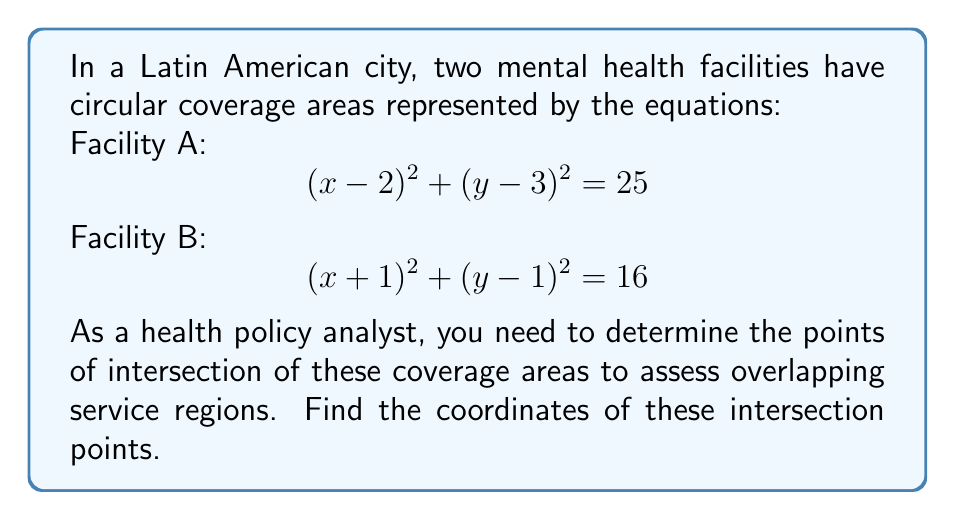Can you solve this math problem? To find the intersection points of these two circular coverage areas, we need to solve the system of equations:

1) $$(x-2)^2 + (y-3)^2 = 25$$
2) $$(x+1)^2 + (y-1)^2 = 16$$

Step 1: Expand the equations
1) $$x^2 - 4x + 4 + y^2 - 6y + 9 = 25$$
2) $$x^2 + 2x + 1 + y^2 - 2y + 1 = 16$$

Step 2: Simplify
1) $$x^2 + y^2 - 4x - 6y - 12 = 0$$
2) $$x^2 + y^2 + 2x - 2y - 14 = 0$$

Step 3: Subtract equation 2 from equation 1
$$-6x - 4y + 2 = 0$$

Step 4: Solve for y
$$y = -\frac{3x}{2} + \frac{1}{2}$$

Step 5: Substitute this expression for y into equation 1
$$x^2 + (-\frac{3x}{2} + \frac{1}{2})^2 - 4x - 6(-\frac{3x}{2} + \frac{1}{2}) - 12 = 0$$

Step 6: Simplify and solve for x
This results in a quadratic equation in x. Solving it gives:
$$x = 4$$ or $$x = -1$$

Step 7: Find corresponding y values
For $$x = 4$$: $$y = -\frac{3(4)}{2} + \frac{1}{2} = -5.5$$
For $$x = -1$$: $$y = -\frac{3(-1)}{2} + \frac{1}{2} = 2$$

Therefore, the intersection points are (4, -5.5) and (-1, 2).
Answer: (4, -5.5) and (-1, 2) 